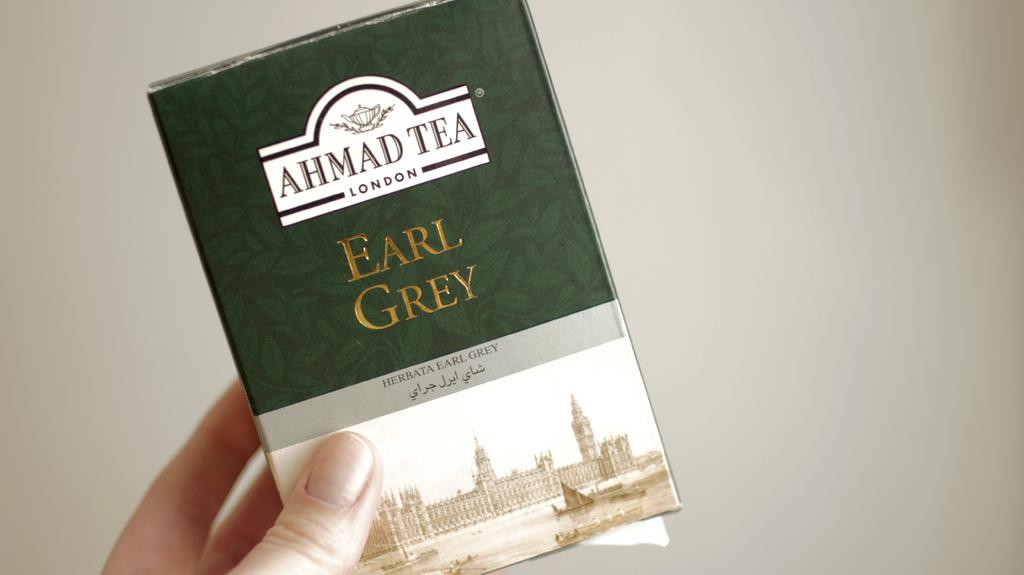Provide a one-sentence caption for the provided image. A hand is holding a bax of Earl Grey from Ahmad Tea. 